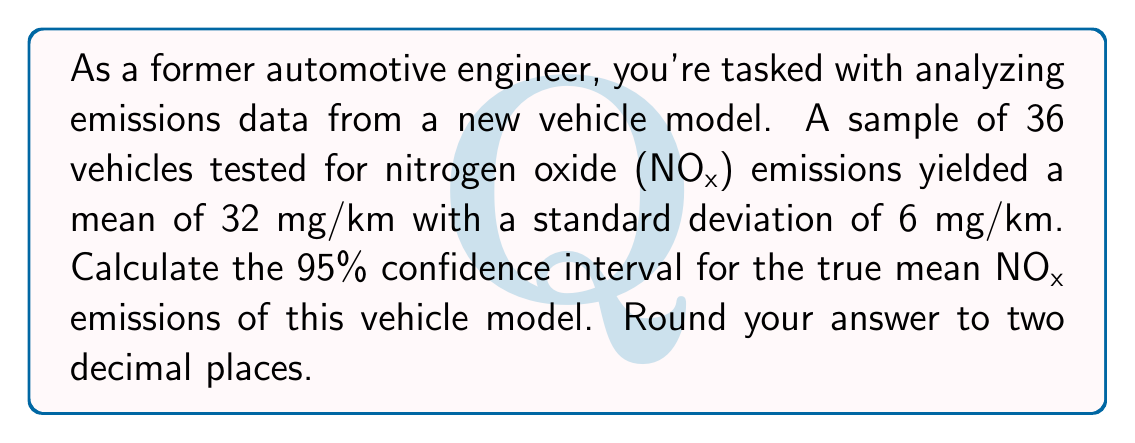Could you help me with this problem? Let's approach this step-by-step:

1) We're given:
   - Sample size: $n = 36$
   - Sample mean: $\bar{x} = 32$ mg/km
   - Sample standard deviation: $s = 6$ mg/km
   - Confidence level: 95%

2) The formula for the confidence interval is:

   $$\bar{x} \pm t_{\alpha/2} \cdot \frac{s}{\sqrt{n}}$$

   where $t_{\alpha/2}$ is the t-value for a 95% confidence interval with $n-1$ degrees of freedom.

3) For a 95% confidence interval, $\alpha = 0.05$, and $\alpha/2 = 0.025$.

4) With 35 degrees of freedom (36 - 1), we can look up or calculate that $t_{0.025} = 2.0301$.

5) Now, let's calculate the margin of error:

   $$\text{Margin of Error} = t_{\alpha/2} \cdot \frac{s}{\sqrt{n}} = 2.0301 \cdot \frac{6}{\sqrt{36}} = 2.0301 \cdot 1 = 2.0301$$

6) Therefore, the confidence interval is:

   $$32 \pm 2.0301$$

7) This gives us:
   Lower bound: $32 - 2.0301 = 29.9699$
   Upper bound: $32 + 2.0301 = 34.0301$

8) Rounding to two decimal places:
   $$(29.97, 34.03)$$
Answer: (29.97, 34.03) mg/km 